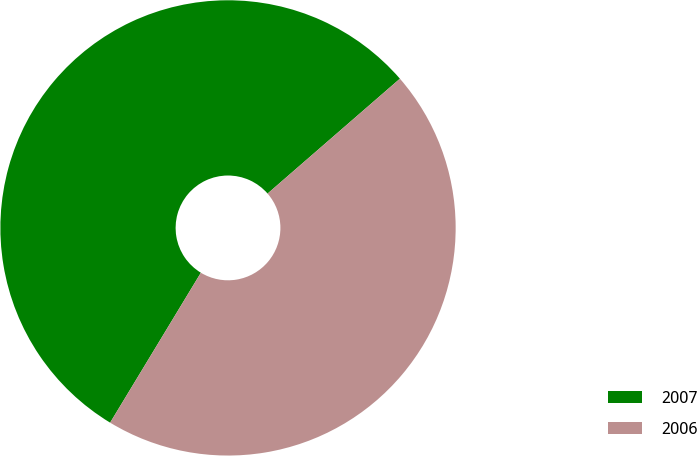<chart> <loc_0><loc_0><loc_500><loc_500><pie_chart><fcel>2007<fcel>2006<nl><fcel>54.96%<fcel>45.04%<nl></chart> 